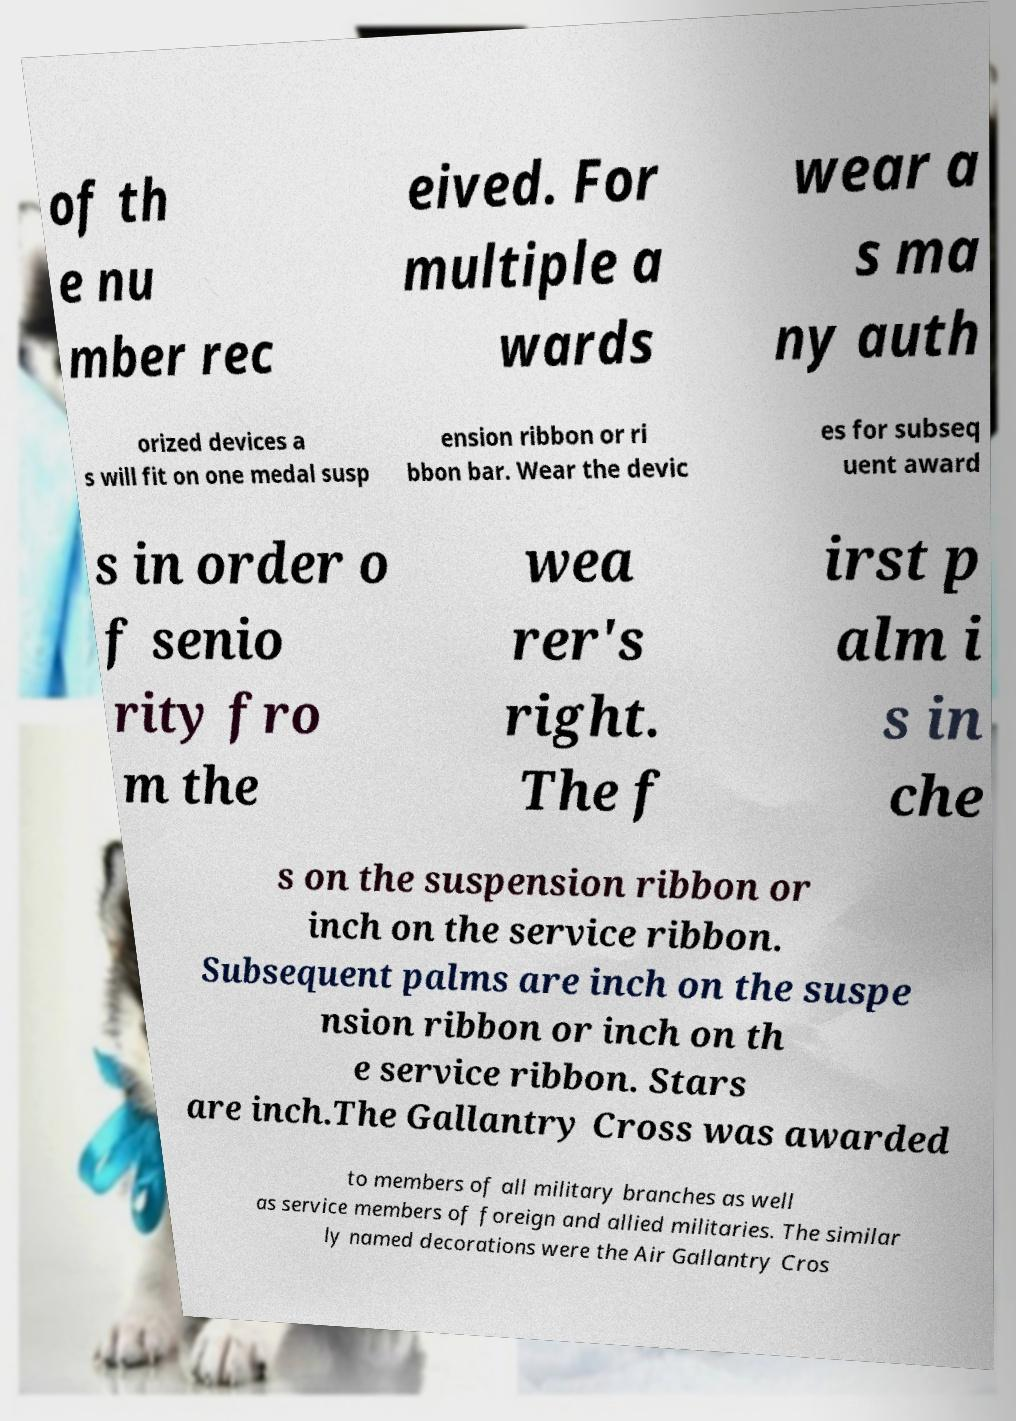Please read and relay the text visible in this image. What does it say? of th e nu mber rec eived. For multiple a wards wear a s ma ny auth orized devices a s will fit on one medal susp ension ribbon or ri bbon bar. Wear the devic es for subseq uent award s in order o f senio rity fro m the wea rer's right. The f irst p alm i s in che s on the suspension ribbon or inch on the service ribbon. Subsequent palms are inch on the suspe nsion ribbon or inch on th e service ribbon. Stars are inch.The Gallantry Cross was awarded to members of all military branches as well as service members of foreign and allied militaries. The similar ly named decorations were the Air Gallantry Cros 